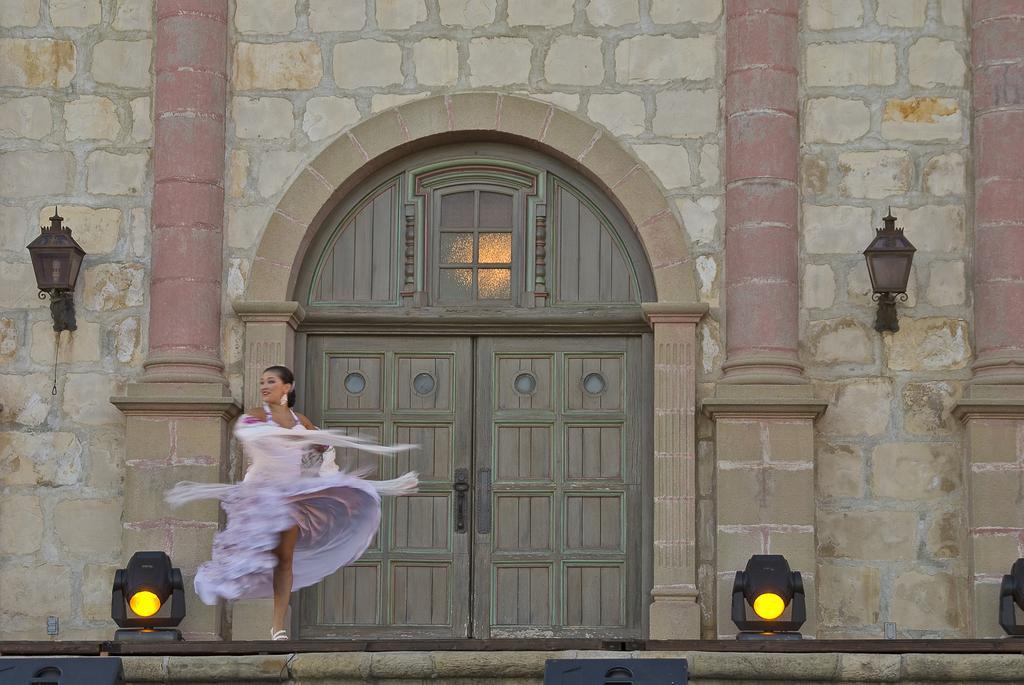Please provide a concise description of this image. In this image there is are pillars, lamps attached to the wall , door visible in the middle, in front of a door there is a woman beside the women there are two lights visible on floor at the bottom. 